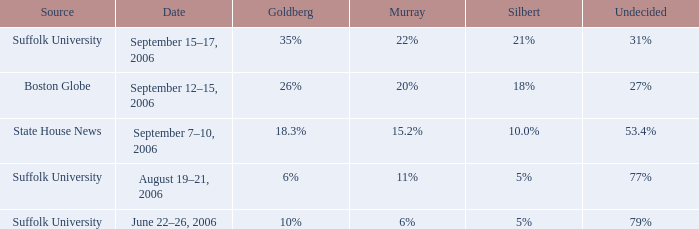What is the date of the survey with goldberg at 26%? September 12–15, 2006. 